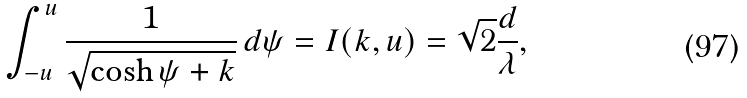Convert formula to latex. <formula><loc_0><loc_0><loc_500><loc_500>\int _ { - u } ^ { u } \frac { 1 } { \sqrt { \cosh \psi + k } } \, d \psi = I ( k , u ) = \sqrt { 2 } \frac { d } { \lambda } ,</formula> 